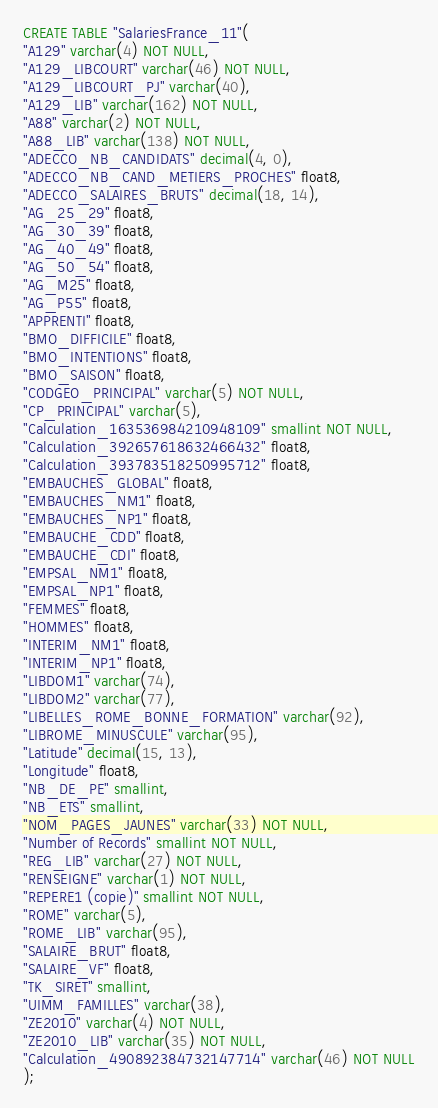Convert code to text. <code><loc_0><loc_0><loc_500><loc_500><_SQL_>CREATE TABLE "SalariesFrance_11"(
"A129" varchar(4) NOT NULL,
"A129_LIBCOURT" varchar(46) NOT NULL,
"A129_LIBCOURT_PJ" varchar(40),
"A129_LIB" varchar(162) NOT NULL,
"A88" varchar(2) NOT NULL,
"A88_LIB" varchar(138) NOT NULL,
"ADECCO_NB_CANDIDATS" decimal(4, 0),
"ADECCO_NB_CAND_METIERS_PROCHES" float8,
"ADECCO_SALAIRES_BRUTS" decimal(18, 14),
"AG_25_29" float8,
"AG_30_39" float8,
"AG_40_49" float8,
"AG_50_54" float8,
"AG_M25" float8,
"AG_P55" float8,
"APPRENTI" float8,
"BMO_DIFFICILE" float8,
"BMO_INTENTIONS" float8,
"BMO_SAISON" float8,
"CODGEO_PRINCIPAL" varchar(5) NOT NULL,
"CP_PRINCIPAL" varchar(5),
"Calculation_163536984210948109" smallint NOT NULL,
"Calculation_392657618632466432" float8,
"Calculation_393783518250995712" float8,
"EMBAUCHES_GLOBAL" float8,
"EMBAUCHES_NM1" float8,
"EMBAUCHES_NP1" float8,
"EMBAUCHE_CDD" float8,
"EMBAUCHE_CDI" float8,
"EMPSAL_NM1" float8,
"EMPSAL_NP1" float8,
"FEMMES" float8,
"HOMMES" float8,
"INTERIM_NM1" float8,
"INTERIM_NP1" float8,
"LIBDOM1" varchar(74),
"LIBDOM2" varchar(77),
"LIBELLES_ROME_BONNE_FORMATION" varchar(92),
"LIBROME_MINUSCULE" varchar(95),
"Latitude" decimal(15, 13),
"Longitude" float8,
"NB_DE_PE" smallint,
"NB_ETS" smallint,
"NOM_PAGES_JAUNES" varchar(33) NOT NULL,
"Number of Records" smallint NOT NULL,
"REG_LIB" varchar(27) NOT NULL,
"RENSEIGNE" varchar(1) NOT NULL,
"REPERE1 (copie)" smallint NOT NULL,
"ROME" varchar(5),
"ROME_LIB" varchar(95),
"SALAIRE_BRUT" float8,
"SALAIRE_VF" float8,
"TK_SIRET" smallint,
"UIMM_FAMILLES" varchar(38),
"ZE2010" varchar(4) NOT NULL,
"ZE2010_LIB" varchar(35) NOT NULL,
"Calculation_490892384732147714" varchar(46) NOT NULL
);
</code> 